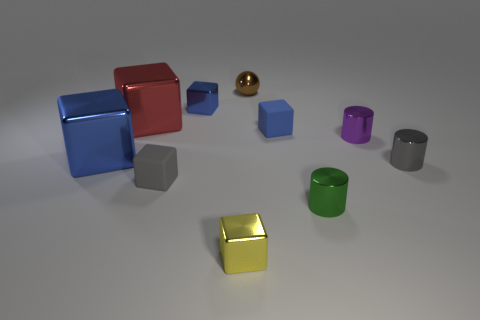What is the size of the metal thing that is both in front of the brown sphere and behind the big red object?
Keep it short and to the point. Small. Is the blue rubber block the same size as the green shiny cylinder?
Your answer should be very brief. Yes. There is a big blue object; what number of rubber things are in front of it?
Keep it short and to the point. 1. Are there more metal objects than blue shiny blocks?
Ensure brevity in your answer.  Yes. What shape is the thing that is in front of the gray metallic cylinder and behind the small green cylinder?
Provide a succinct answer. Cube. Is there a small purple metal cube?
Keep it short and to the point. No. There is a purple object that is the same shape as the green object; what is its material?
Give a very brief answer. Metal. There is a small gray thing right of the small matte cube on the left side of the thing in front of the tiny green metal thing; what is its shape?
Offer a terse response. Cylinder. What number of tiny metal things have the same shape as the large red thing?
Give a very brief answer. 2. Is the color of the tiny matte cube behind the small gray metal object the same as the small metallic thing that is in front of the green shiny object?
Your answer should be compact. No. 